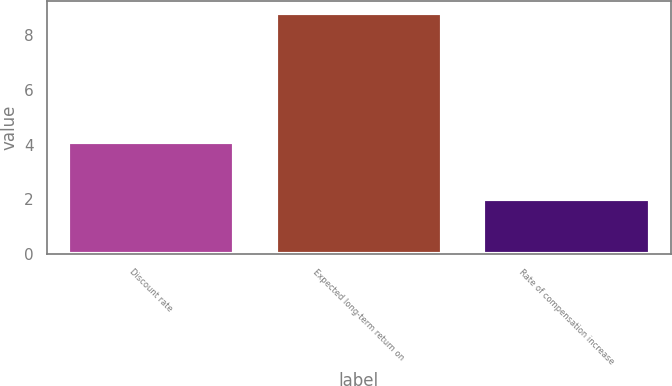Convert chart to OTSL. <chart><loc_0><loc_0><loc_500><loc_500><bar_chart><fcel>Discount rate<fcel>Expected long-term return on<fcel>Rate of compensation increase<nl><fcel>4.1<fcel>8.8<fcel>2<nl></chart> 